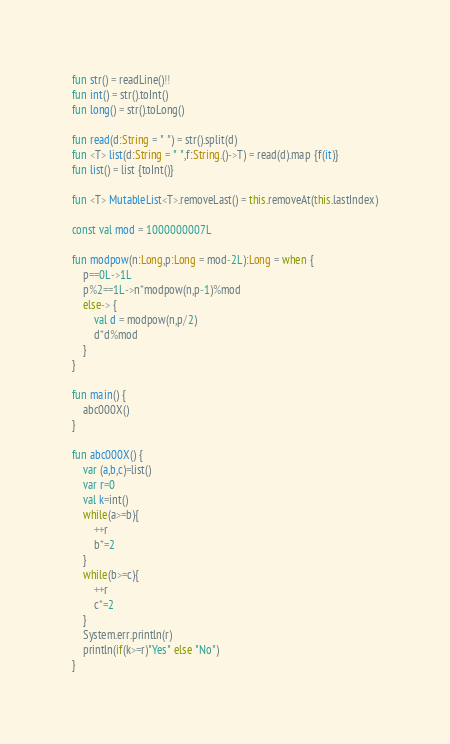Convert code to text. <code><loc_0><loc_0><loc_500><loc_500><_Kotlin_>fun str() = readLine()!!
fun int() = str().toInt()
fun long() = str().toLong()

fun read(d:String = " ") = str().split(d)
fun <T> list(d:String = " ",f:String.()->T) = read(d).map {f(it)}
fun list() = list {toInt()}

fun <T> MutableList<T>.removeLast() = this.removeAt(this.lastIndex)

const val mod = 1000000007L

fun modpow(n:Long,p:Long = mod-2L):Long = when {
	p==0L->1L
	p%2==1L->n*modpow(n,p-1)%mod
	else-> {
		val d = modpow(n,p/2)
		d*d%mod
	}
}

fun main() {
	abc000X()
}

fun abc000X() {
	var (a,b,c)=list()
	var r=0
	val k=int()
	while(a>=b){
		++r
		b*=2
	}
	while(b>=c){
		++r
		c*=2
	}
	System.err.println(r)
	println(if(k>=r)"Yes" else "No")
}
</code> 